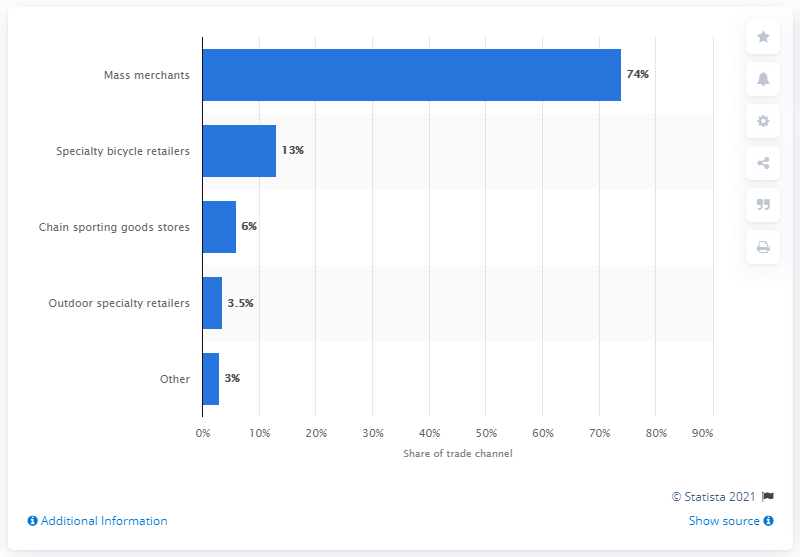Give some essential details in this illustration. In 2015, mass merchants accounted for 74% of the retail bicycle market. 